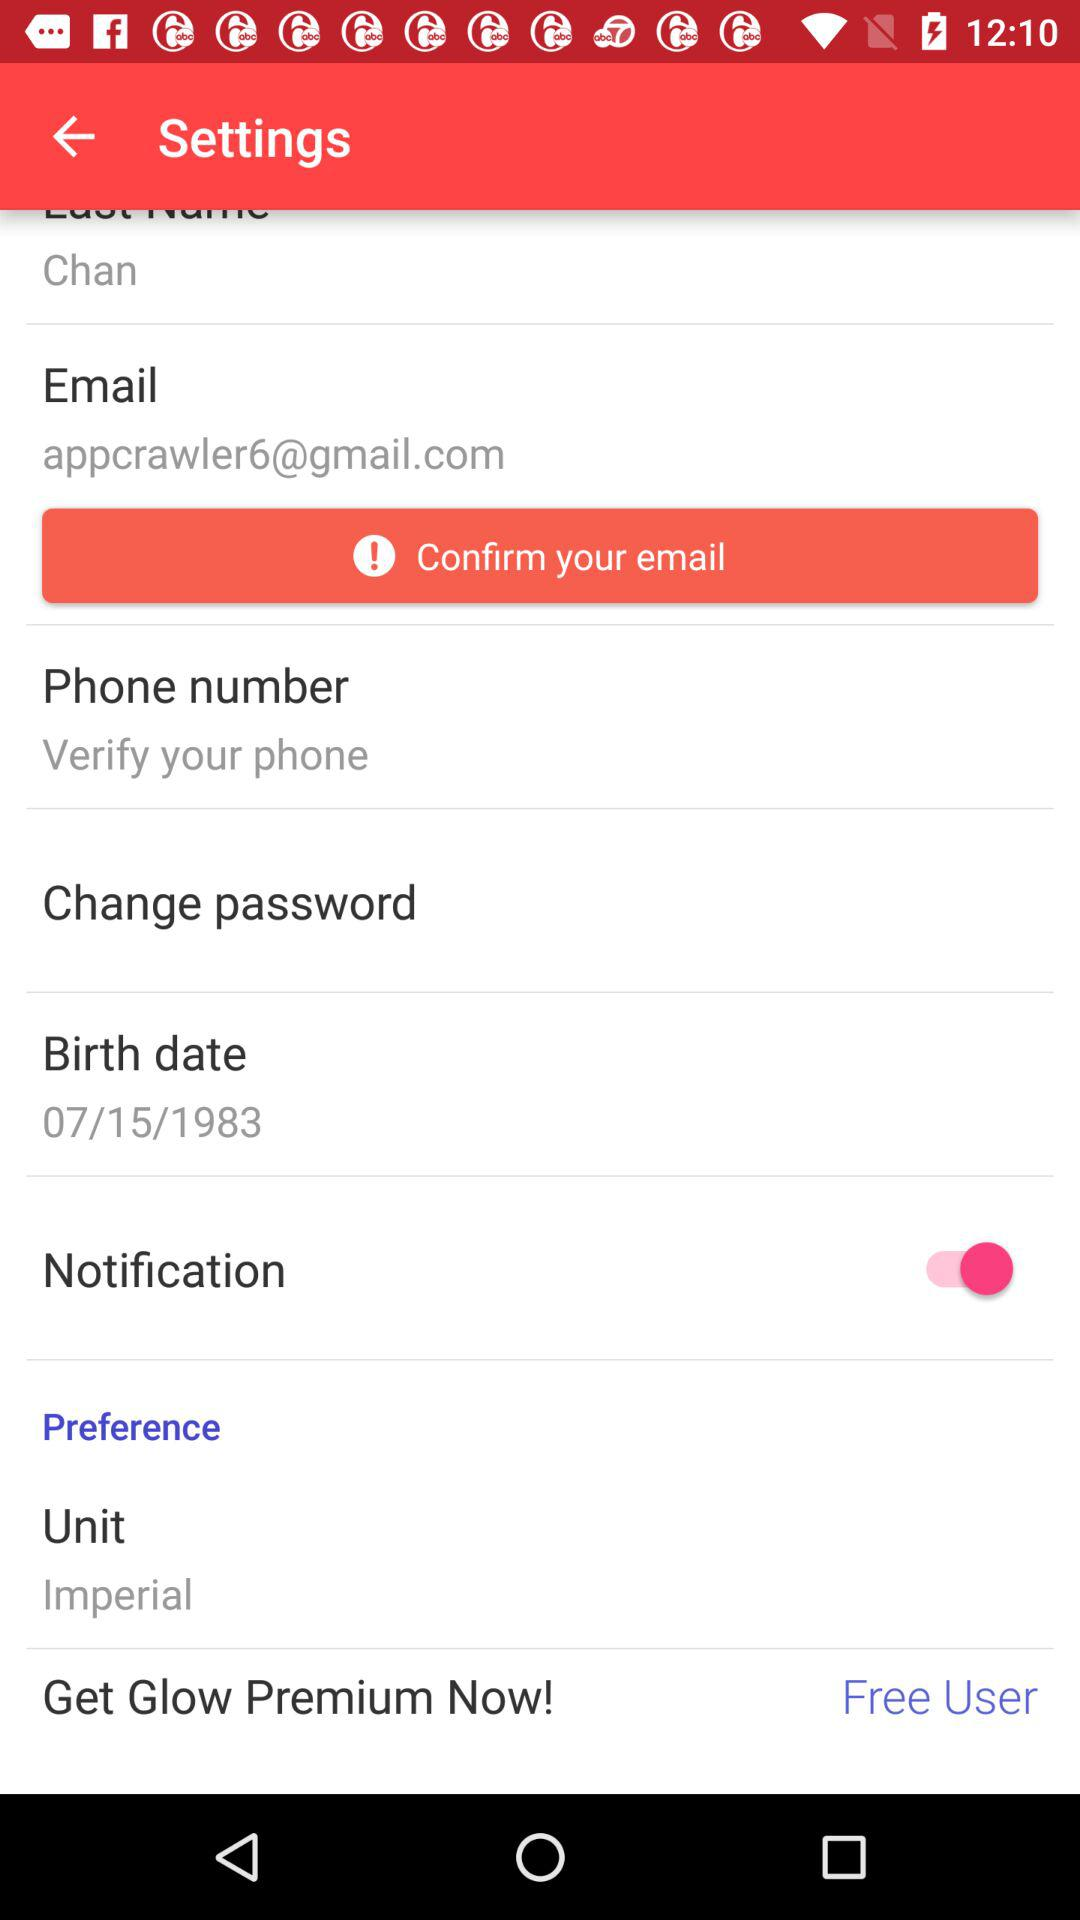What is the date of birth? The date of birth is July 15, 1983. 